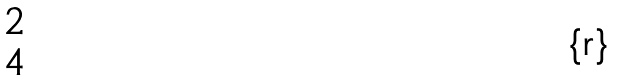Convert formula to latex. <formula><loc_0><loc_0><loc_500><loc_500>\begin{matrix} 2 \\ 4 \end{matrix}</formula> 